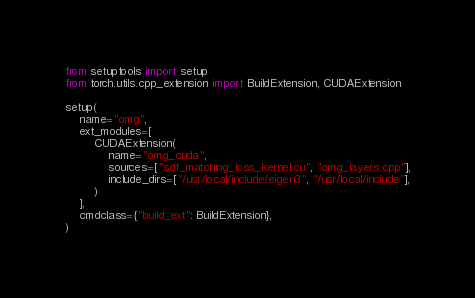<code> <loc_0><loc_0><loc_500><loc_500><_Python_>from setuptools import setup
from torch.utils.cpp_extension import BuildExtension, CUDAExtension

setup(
    name="omg",
    ext_modules=[
        CUDAExtension(
            name="omg_cuda",
            sources=["sdf_matching_loss_kernel.cu", "omg_layers.cpp"],
            include_dirs=["/usr/local/include/eigen3", "/usr/local/include"],
        )
    ],
    cmdclass={"build_ext": BuildExtension},
)
</code> 